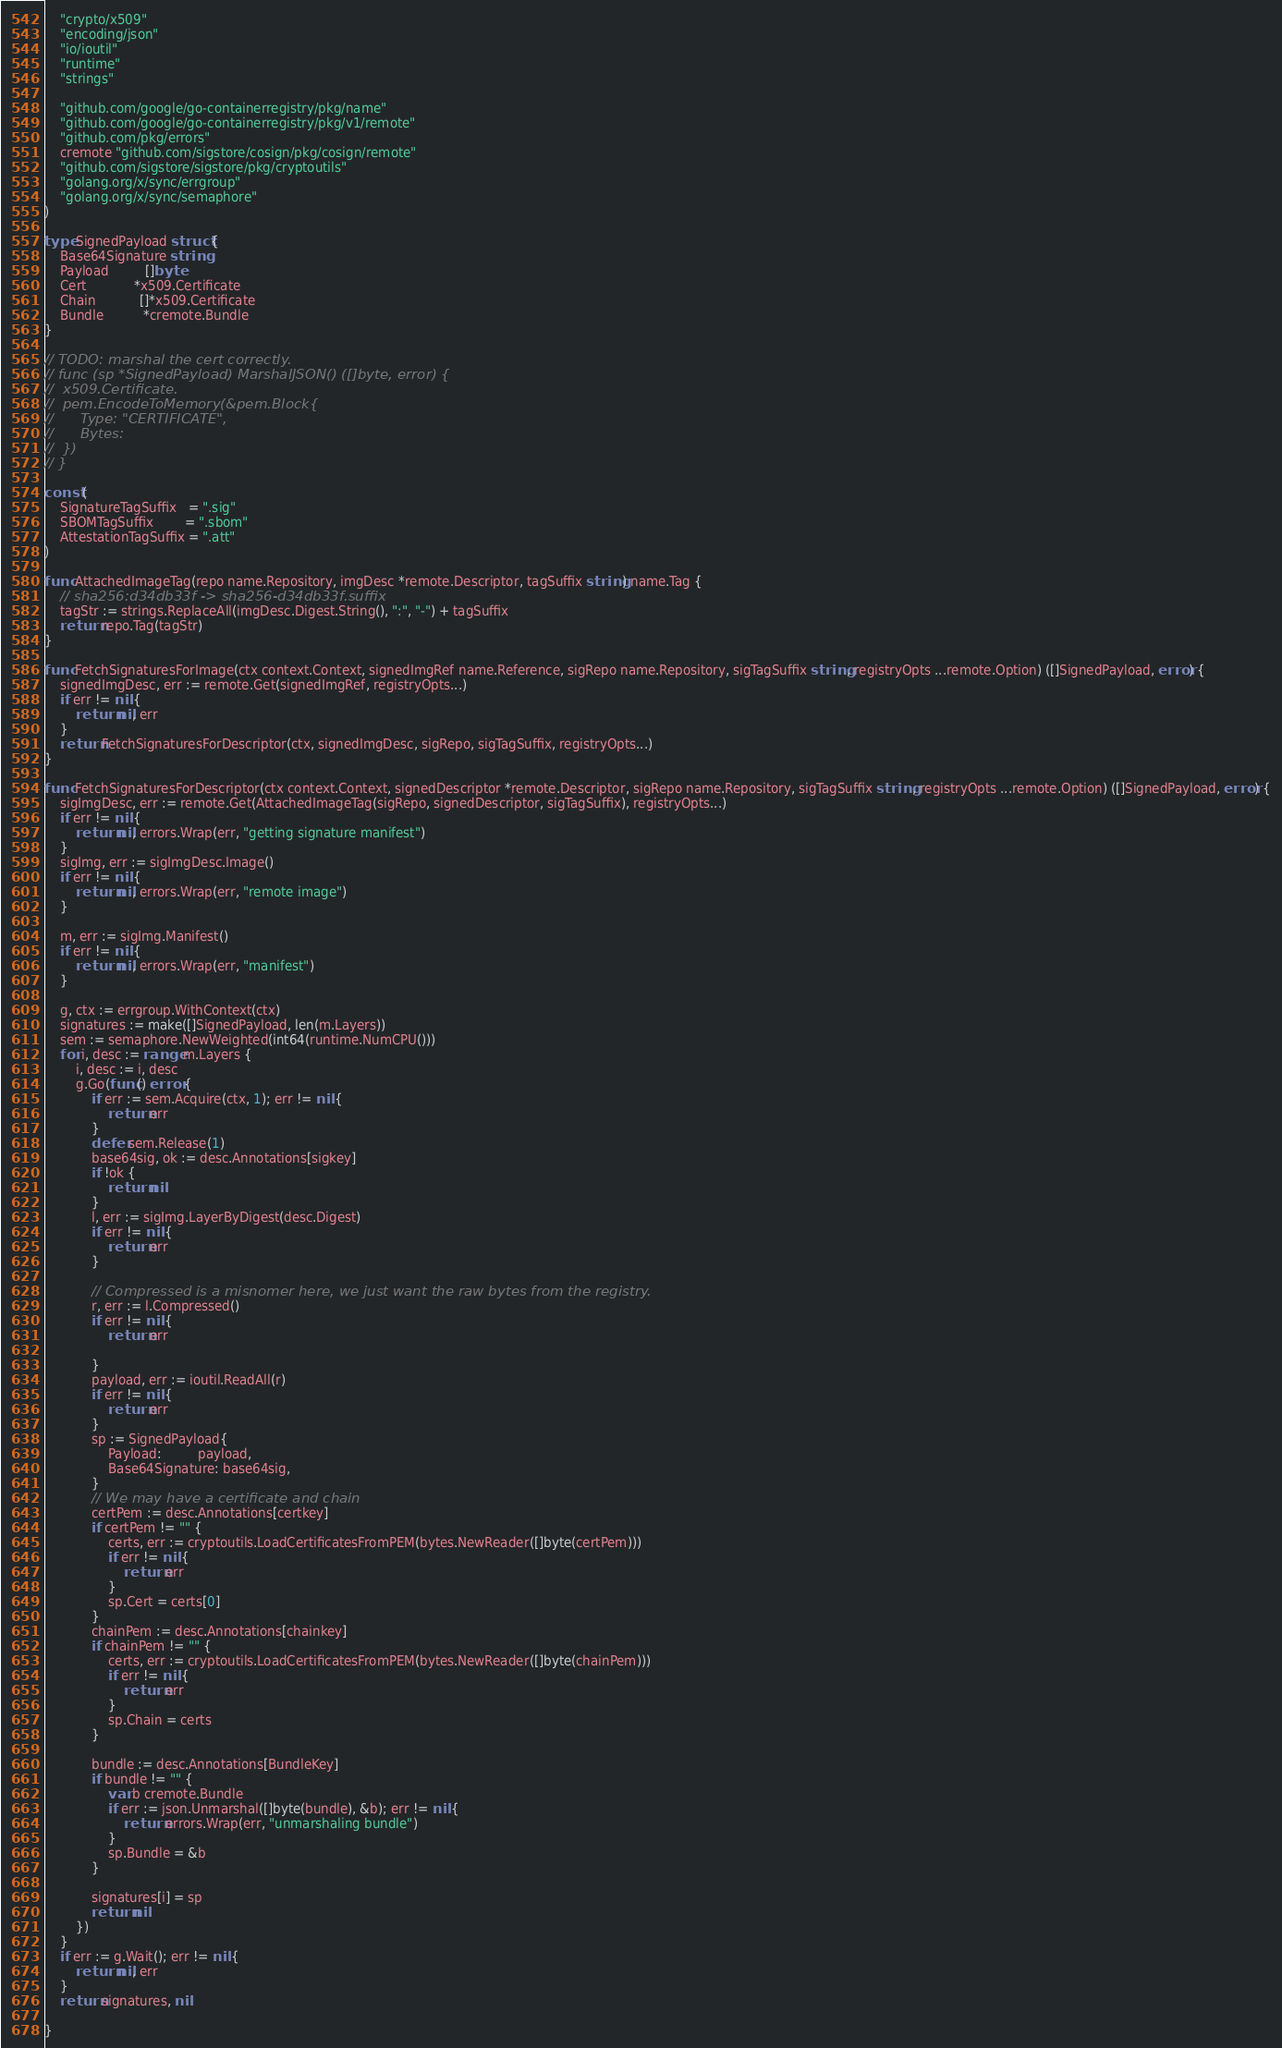Convert code to text. <code><loc_0><loc_0><loc_500><loc_500><_Go_>	"crypto/x509"
	"encoding/json"
	"io/ioutil"
	"runtime"
	"strings"

	"github.com/google/go-containerregistry/pkg/name"
	"github.com/google/go-containerregistry/pkg/v1/remote"
	"github.com/pkg/errors"
	cremote "github.com/sigstore/cosign/pkg/cosign/remote"
	"github.com/sigstore/sigstore/pkg/cryptoutils"
	"golang.org/x/sync/errgroup"
	"golang.org/x/sync/semaphore"
)

type SignedPayload struct {
	Base64Signature string
	Payload         []byte
	Cert            *x509.Certificate
	Chain           []*x509.Certificate
	Bundle          *cremote.Bundle
}

// TODO: marshal the cert correctly.
// func (sp *SignedPayload) MarshalJSON() ([]byte, error) {
// 	x509.Certificate.
// 	pem.EncodeToMemory(&pem.Block{
// 		Type: "CERTIFICATE",
// 		Bytes:
// 	})
// }

const (
	SignatureTagSuffix   = ".sig"
	SBOMTagSuffix        = ".sbom"
	AttestationTagSuffix = ".att"
)

func AttachedImageTag(repo name.Repository, imgDesc *remote.Descriptor, tagSuffix string) name.Tag {
	// sha256:d34db33f -> sha256-d34db33f.suffix
	tagStr := strings.ReplaceAll(imgDesc.Digest.String(), ":", "-") + tagSuffix
	return repo.Tag(tagStr)
}

func FetchSignaturesForImage(ctx context.Context, signedImgRef name.Reference, sigRepo name.Repository, sigTagSuffix string, registryOpts ...remote.Option) ([]SignedPayload, error) {
	signedImgDesc, err := remote.Get(signedImgRef, registryOpts...)
	if err != nil {
		return nil, err
	}
	return FetchSignaturesForDescriptor(ctx, signedImgDesc, sigRepo, sigTagSuffix, registryOpts...)
}

func FetchSignaturesForDescriptor(ctx context.Context, signedDescriptor *remote.Descriptor, sigRepo name.Repository, sigTagSuffix string, registryOpts ...remote.Option) ([]SignedPayload, error) {
	sigImgDesc, err := remote.Get(AttachedImageTag(sigRepo, signedDescriptor, sigTagSuffix), registryOpts...)
	if err != nil {
		return nil, errors.Wrap(err, "getting signature manifest")
	}
	sigImg, err := sigImgDesc.Image()
	if err != nil {
		return nil, errors.Wrap(err, "remote image")
	}

	m, err := sigImg.Manifest()
	if err != nil {
		return nil, errors.Wrap(err, "manifest")
	}

	g, ctx := errgroup.WithContext(ctx)
	signatures := make([]SignedPayload, len(m.Layers))
	sem := semaphore.NewWeighted(int64(runtime.NumCPU()))
	for i, desc := range m.Layers {
		i, desc := i, desc
		g.Go(func() error {
			if err := sem.Acquire(ctx, 1); err != nil {
				return err
			}
			defer sem.Release(1)
			base64sig, ok := desc.Annotations[sigkey]
			if !ok {
				return nil
			}
			l, err := sigImg.LayerByDigest(desc.Digest)
			if err != nil {
				return err
			}

			// Compressed is a misnomer here, we just want the raw bytes from the registry.
			r, err := l.Compressed()
			if err != nil {
				return err

			}
			payload, err := ioutil.ReadAll(r)
			if err != nil {
				return err
			}
			sp := SignedPayload{
				Payload:         payload,
				Base64Signature: base64sig,
			}
			// We may have a certificate and chain
			certPem := desc.Annotations[certkey]
			if certPem != "" {
				certs, err := cryptoutils.LoadCertificatesFromPEM(bytes.NewReader([]byte(certPem)))
				if err != nil {
					return err
				}
				sp.Cert = certs[0]
			}
			chainPem := desc.Annotations[chainkey]
			if chainPem != "" {
				certs, err := cryptoutils.LoadCertificatesFromPEM(bytes.NewReader([]byte(chainPem)))
				if err != nil {
					return err
				}
				sp.Chain = certs
			}

			bundle := desc.Annotations[BundleKey]
			if bundle != "" {
				var b cremote.Bundle
				if err := json.Unmarshal([]byte(bundle), &b); err != nil {
					return errors.Wrap(err, "unmarshaling bundle")
				}
				sp.Bundle = &b
			}

			signatures[i] = sp
			return nil
		})
	}
	if err := g.Wait(); err != nil {
		return nil, err
	}
	return signatures, nil

}
</code> 